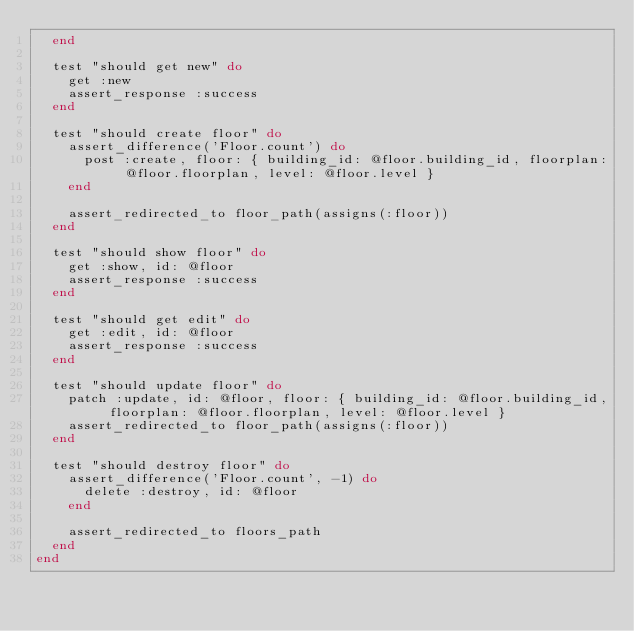<code> <loc_0><loc_0><loc_500><loc_500><_Ruby_>  end

  test "should get new" do
    get :new
    assert_response :success
  end

  test "should create floor" do
    assert_difference('Floor.count') do
      post :create, floor: { building_id: @floor.building_id, floorplan: @floor.floorplan, level: @floor.level }
    end

    assert_redirected_to floor_path(assigns(:floor))
  end

  test "should show floor" do
    get :show, id: @floor
    assert_response :success
  end

  test "should get edit" do
    get :edit, id: @floor
    assert_response :success
  end

  test "should update floor" do
    patch :update, id: @floor, floor: { building_id: @floor.building_id, floorplan: @floor.floorplan, level: @floor.level }
    assert_redirected_to floor_path(assigns(:floor))
  end

  test "should destroy floor" do
    assert_difference('Floor.count', -1) do
      delete :destroy, id: @floor
    end

    assert_redirected_to floors_path
  end
end
</code> 